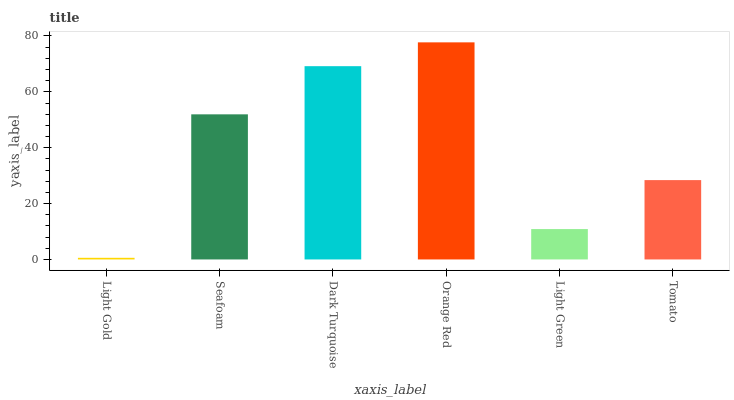Is Seafoam the minimum?
Answer yes or no. No. Is Seafoam the maximum?
Answer yes or no. No. Is Seafoam greater than Light Gold?
Answer yes or no. Yes. Is Light Gold less than Seafoam?
Answer yes or no. Yes. Is Light Gold greater than Seafoam?
Answer yes or no. No. Is Seafoam less than Light Gold?
Answer yes or no. No. Is Seafoam the high median?
Answer yes or no. Yes. Is Tomato the low median?
Answer yes or no. Yes. Is Orange Red the high median?
Answer yes or no. No. Is Orange Red the low median?
Answer yes or no. No. 